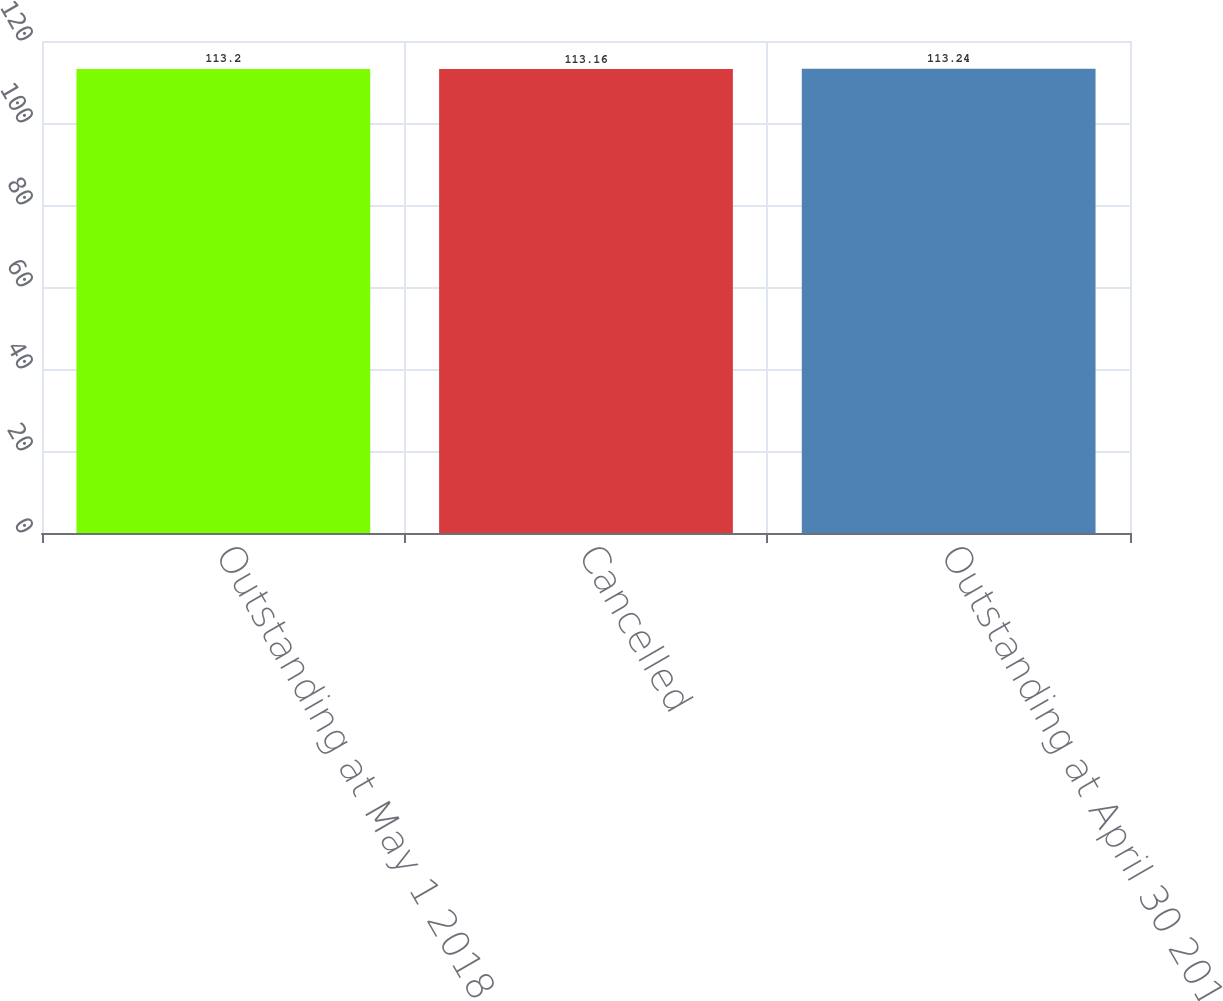Convert chart to OTSL. <chart><loc_0><loc_0><loc_500><loc_500><bar_chart><fcel>Outstanding at May 1 2018<fcel>Cancelled<fcel>Outstanding at April 30 2019<nl><fcel>113.2<fcel>113.16<fcel>113.24<nl></chart> 